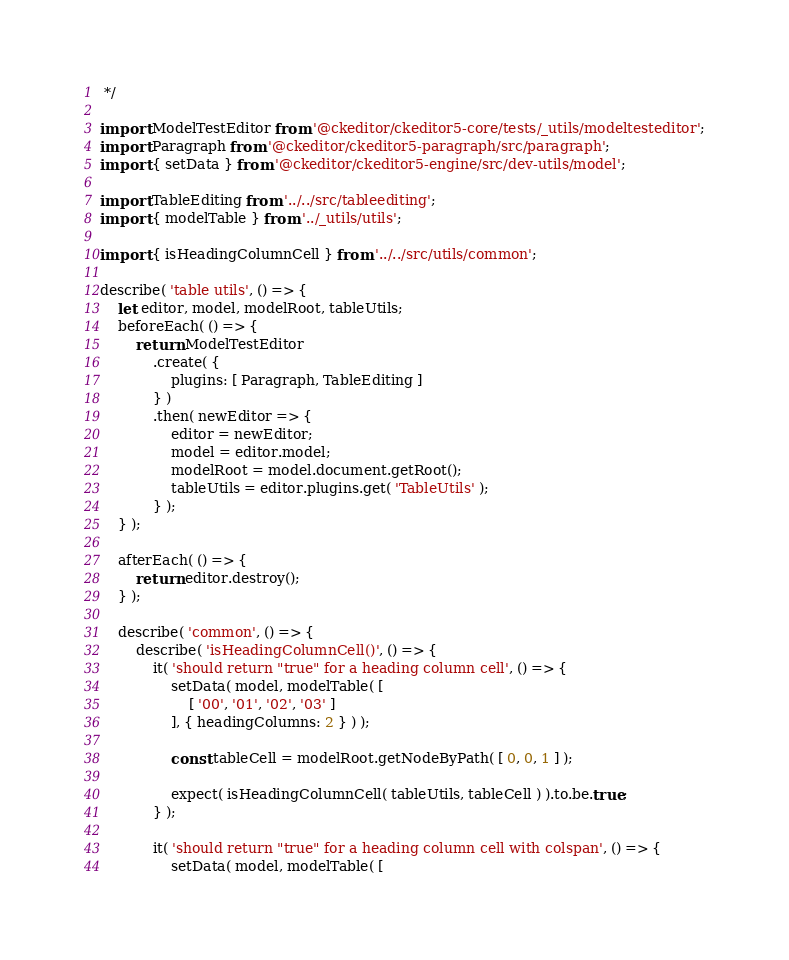Convert code to text. <code><loc_0><loc_0><loc_500><loc_500><_JavaScript_> */

import ModelTestEditor from '@ckeditor/ckeditor5-core/tests/_utils/modeltesteditor';
import Paragraph from '@ckeditor/ckeditor5-paragraph/src/paragraph';
import { setData } from '@ckeditor/ckeditor5-engine/src/dev-utils/model';

import TableEditing from '../../src/tableediting';
import { modelTable } from '../_utils/utils';

import { isHeadingColumnCell } from '../../src/utils/common';

describe( 'table utils', () => {
	let editor, model, modelRoot, tableUtils;
	beforeEach( () => {
		return ModelTestEditor
			.create( {
				plugins: [ Paragraph, TableEditing ]
			} )
			.then( newEditor => {
				editor = newEditor;
				model = editor.model;
				modelRoot = model.document.getRoot();
				tableUtils = editor.plugins.get( 'TableUtils' );
			} );
	} );

	afterEach( () => {
		return editor.destroy();
	} );

	describe( 'common', () => {
		describe( 'isHeadingColumnCell()', () => {
			it( 'should return "true" for a heading column cell', () => {
				setData( model, modelTable( [
					[ '00', '01', '02', '03' ]
				], { headingColumns: 2 } ) );

				const tableCell = modelRoot.getNodeByPath( [ 0, 0, 1 ] );

				expect( isHeadingColumnCell( tableUtils, tableCell ) ).to.be.true;
			} );

			it( 'should return "true" for a heading column cell with colspan', () => {
				setData( model, modelTable( [</code> 